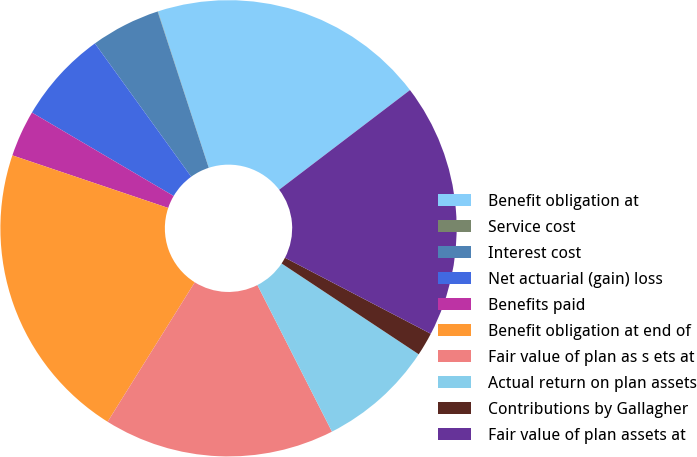<chart> <loc_0><loc_0><loc_500><loc_500><pie_chart><fcel>Benefit obligation at<fcel>Service cost<fcel>Interest cost<fcel>Net actuarial (gain) loss<fcel>Benefits paid<fcel>Benefit obligation at end of<fcel>Fair value of plan as s ets at<fcel>Actual return on plan assets<fcel>Contributions by Gallagher<fcel>Fair value of plan assets at<nl><fcel>19.65%<fcel>0.02%<fcel>4.93%<fcel>6.57%<fcel>3.29%<fcel>21.29%<fcel>16.38%<fcel>8.2%<fcel>1.66%<fcel>18.01%<nl></chart> 